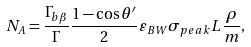Convert formula to latex. <formula><loc_0><loc_0><loc_500><loc_500>N _ { A } = \frac { \Gamma _ { b \beta } } { \Gamma } \frac { 1 - \cos \theta ^ { \prime } } { 2 } \varepsilon _ { B W } \sigma _ { p e a k } L \frac { \rho } { m } ,</formula> 